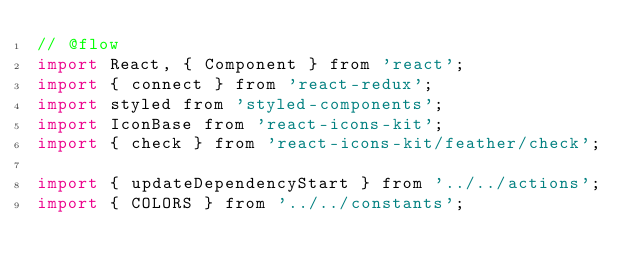Convert code to text. <code><loc_0><loc_0><loc_500><loc_500><_JavaScript_>// @flow
import React, { Component } from 'react';
import { connect } from 'react-redux';
import styled from 'styled-components';
import IconBase from 'react-icons-kit';
import { check } from 'react-icons-kit/feather/check';

import { updateDependencyStart } from '../../actions';
import { COLORS } from '../../constants';</code> 